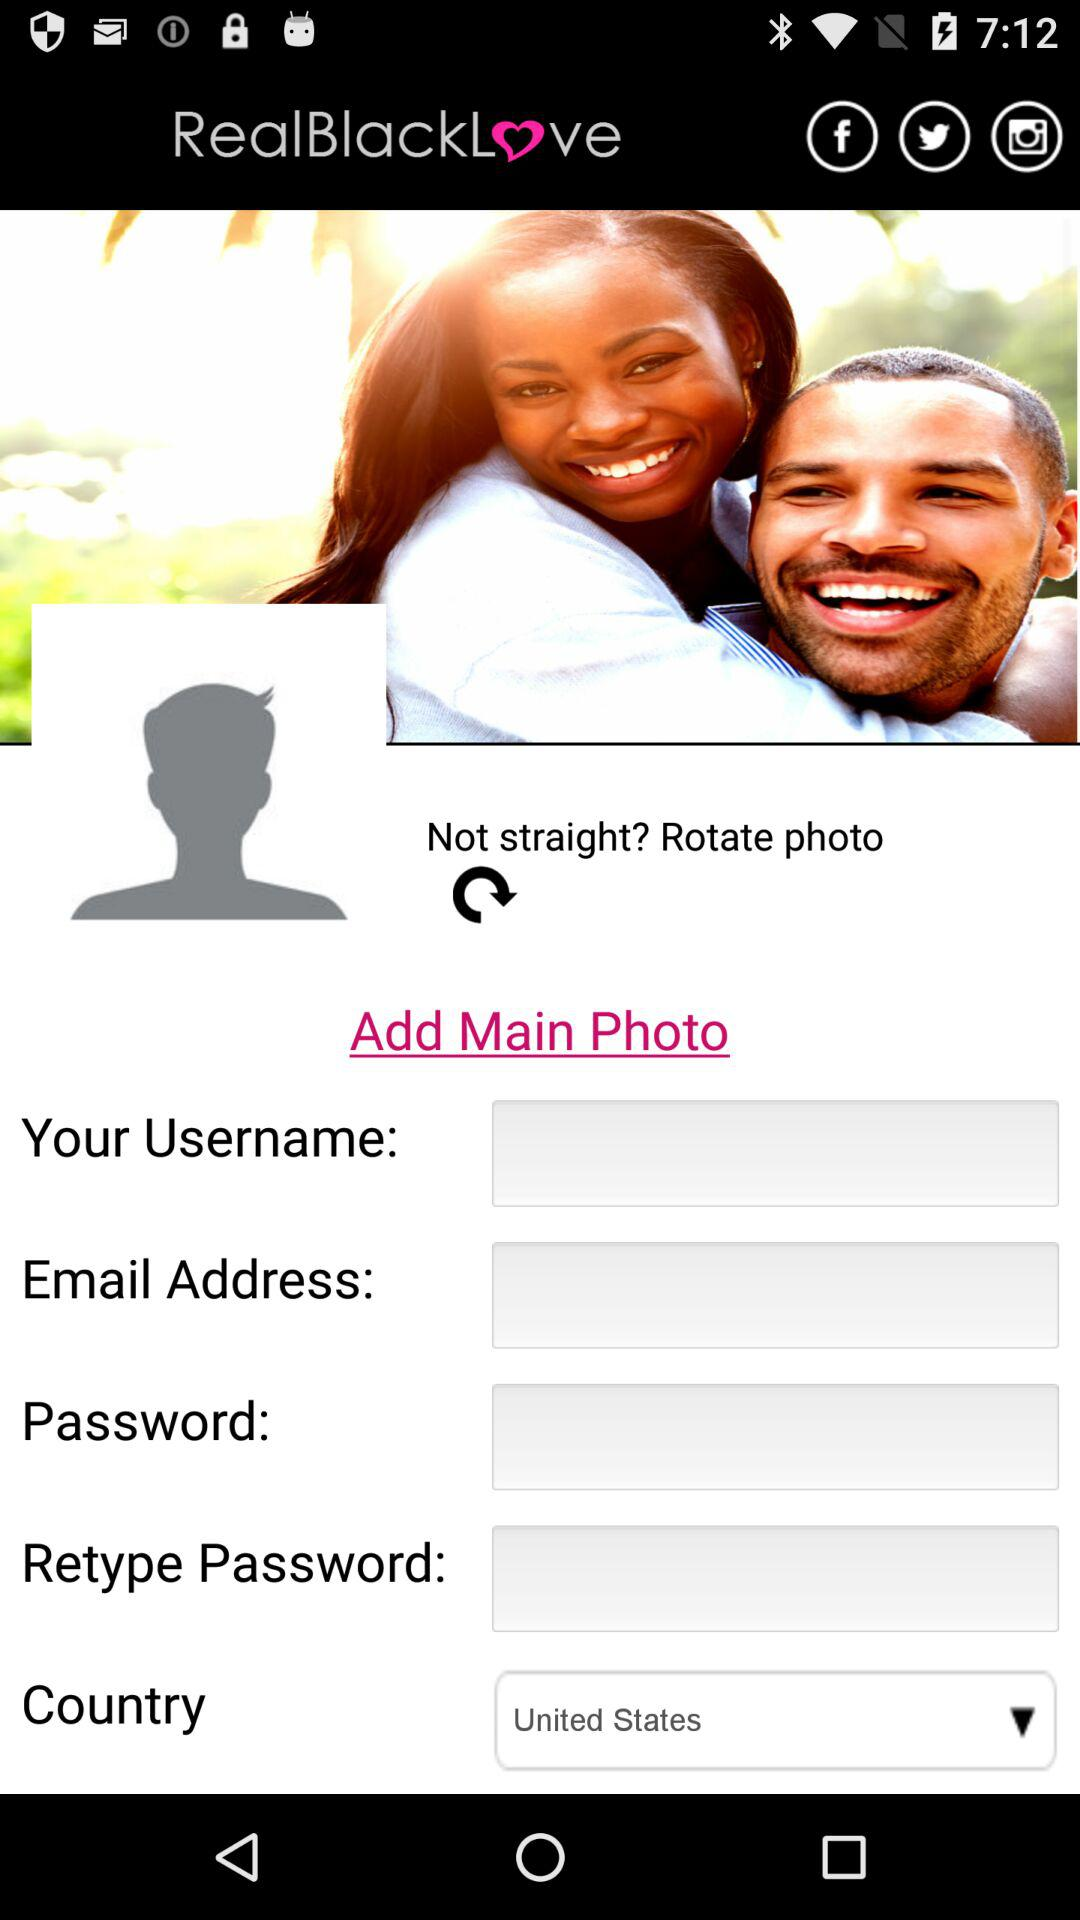Which country is selected? The selected country is the United States. 